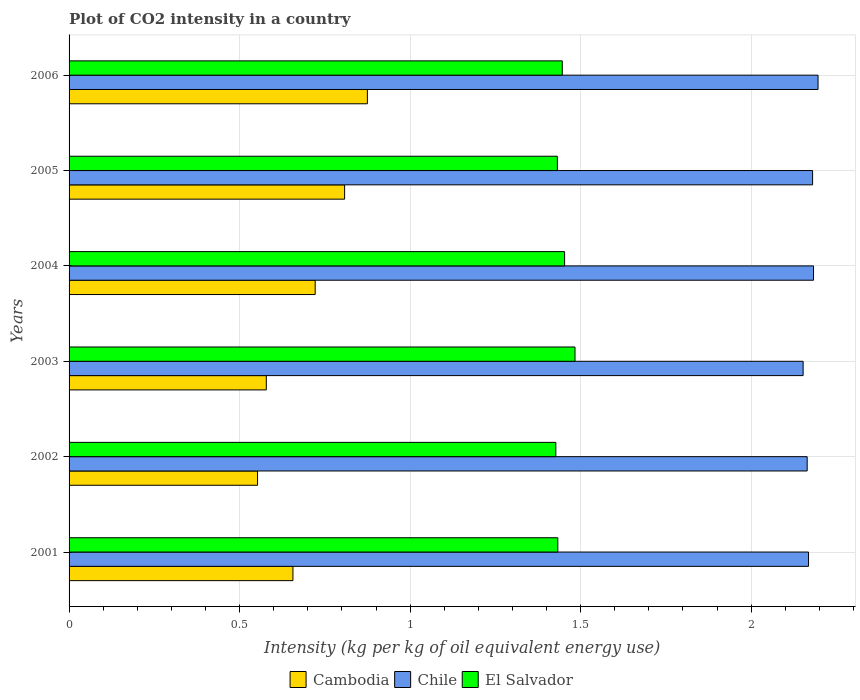How many different coloured bars are there?
Offer a very short reply. 3. Are the number of bars per tick equal to the number of legend labels?
Your answer should be very brief. Yes. Are the number of bars on each tick of the Y-axis equal?
Keep it short and to the point. Yes. How many bars are there on the 5th tick from the bottom?
Your response must be concise. 3. In how many cases, is the number of bars for a given year not equal to the number of legend labels?
Make the answer very short. 0. What is the CO2 intensity in in El Salvador in 2002?
Your answer should be compact. 1.43. Across all years, what is the maximum CO2 intensity in in El Salvador?
Your response must be concise. 1.48. Across all years, what is the minimum CO2 intensity in in Chile?
Your response must be concise. 2.15. What is the total CO2 intensity in in El Salvador in the graph?
Offer a terse response. 8.67. What is the difference between the CO2 intensity in in El Salvador in 2001 and that in 2006?
Offer a very short reply. -0.01. What is the difference between the CO2 intensity in in Chile in 2003 and the CO2 intensity in in Cambodia in 2002?
Provide a succinct answer. 1.6. What is the average CO2 intensity in in El Salvador per year?
Make the answer very short. 1.45. In the year 2002, what is the difference between the CO2 intensity in in Cambodia and CO2 intensity in in El Salvador?
Provide a succinct answer. -0.87. In how many years, is the CO2 intensity in in Cambodia greater than 2.1 kg?
Your response must be concise. 0. What is the ratio of the CO2 intensity in in El Salvador in 2005 to that in 2006?
Your answer should be compact. 0.99. Is the CO2 intensity in in Chile in 2001 less than that in 2006?
Offer a very short reply. Yes. What is the difference between the highest and the second highest CO2 intensity in in Chile?
Ensure brevity in your answer.  0.01. What is the difference between the highest and the lowest CO2 intensity in in El Salvador?
Your answer should be compact. 0.06. In how many years, is the CO2 intensity in in Chile greater than the average CO2 intensity in in Chile taken over all years?
Your answer should be compact. 3. Is the sum of the CO2 intensity in in Cambodia in 2003 and 2004 greater than the maximum CO2 intensity in in Chile across all years?
Your answer should be compact. No. What does the 1st bar from the top in 2006 represents?
Ensure brevity in your answer.  El Salvador. What does the 2nd bar from the bottom in 2001 represents?
Give a very brief answer. Chile. What is the difference between two consecutive major ticks on the X-axis?
Keep it short and to the point. 0.5. Does the graph contain any zero values?
Keep it short and to the point. No. How many legend labels are there?
Your answer should be very brief. 3. What is the title of the graph?
Provide a succinct answer. Plot of CO2 intensity in a country. What is the label or title of the X-axis?
Your answer should be very brief. Intensity (kg per kg of oil equivalent energy use). What is the label or title of the Y-axis?
Provide a short and direct response. Years. What is the Intensity (kg per kg of oil equivalent energy use) of Cambodia in 2001?
Provide a succinct answer. 0.66. What is the Intensity (kg per kg of oil equivalent energy use) of Chile in 2001?
Make the answer very short. 2.17. What is the Intensity (kg per kg of oil equivalent energy use) in El Salvador in 2001?
Provide a short and direct response. 1.43. What is the Intensity (kg per kg of oil equivalent energy use) in Cambodia in 2002?
Your answer should be compact. 0.55. What is the Intensity (kg per kg of oil equivalent energy use) of Chile in 2002?
Make the answer very short. 2.16. What is the Intensity (kg per kg of oil equivalent energy use) of El Salvador in 2002?
Keep it short and to the point. 1.43. What is the Intensity (kg per kg of oil equivalent energy use) in Cambodia in 2003?
Your answer should be compact. 0.58. What is the Intensity (kg per kg of oil equivalent energy use) of Chile in 2003?
Your answer should be compact. 2.15. What is the Intensity (kg per kg of oil equivalent energy use) of El Salvador in 2003?
Ensure brevity in your answer.  1.48. What is the Intensity (kg per kg of oil equivalent energy use) of Cambodia in 2004?
Provide a short and direct response. 0.72. What is the Intensity (kg per kg of oil equivalent energy use) of Chile in 2004?
Your answer should be very brief. 2.18. What is the Intensity (kg per kg of oil equivalent energy use) of El Salvador in 2004?
Your response must be concise. 1.45. What is the Intensity (kg per kg of oil equivalent energy use) in Cambodia in 2005?
Provide a succinct answer. 0.81. What is the Intensity (kg per kg of oil equivalent energy use) of Chile in 2005?
Provide a short and direct response. 2.18. What is the Intensity (kg per kg of oil equivalent energy use) in El Salvador in 2005?
Ensure brevity in your answer.  1.43. What is the Intensity (kg per kg of oil equivalent energy use) in Cambodia in 2006?
Offer a terse response. 0.87. What is the Intensity (kg per kg of oil equivalent energy use) in Chile in 2006?
Your answer should be compact. 2.2. What is the Intensity (kg per kg of oil equivalent energy use) in El Salvador in 2006?
Provide a succinct answer. 1.45. Across all years, what is the maximum Intensity (kg per kg of oil equivalent energy use) in Cambodia?
Offer a terse response. 0.87. Across all years, what is the maximum Intensity (kg per kg of oil equivalent energy use) of Chile?
Your response must be concise. 2.2. Across all years, what is the maximum Intensity (kg per kg of oil equivalent energy use) in El Salvador?
Ensure brevity in your answer.  1.48. Across all years, what is the minimum Intensity (kg per kg of oil equivalent energy use) in Cambodia?
Your response must be concise. 0.55. Across all years, what is the minimum Intensity (kg per kg of oil equivalent energy use) of Chile?
Provide a succinct answer. 2.15. Across all years, what is the minimum Intensity (kg per kg of oil equivalent energy use) of El Salvador?
Your answer should be compact. 1.43. What is the total Intensity (kg per kg of oil equivalent energy use) in Cambodia in the graph?
Your answer should be compact. 4.19. What is the total Intensity (kg per kg of oil equivalent energy use) in Chile in the graph?
Offer a very short reply. 13.04. What is the total Intensity (kg per kg of oil equivalent energy use) of El Salvador in the graph?
Provide a succinct answer. 8.67. What is the difference between the Intensity (kg per kg of oil equivalent energy use) in Cambodia in 2001 and that in 2002?
Your answer should be compact. 0.1. What is the difference between the Intensity (kg per kg of oil equivalent energy use) in Chile in 2001 and that in 2002?
Ensure brevity in your answer.  0. What is the difference between the Intensity (kg per kg of oil equivalent energy use) of El Salvador in 2001 and that in 2002?
Provide a short and direct response. 0.01. What is the difference between the Intensity (kg per kg of oil equivalent energy use) in Cambodia in 2001 and that in 2003?
Offer a terse response. 0.08. What is the difference between the Intensity (kg per kg of oil equivalent energy use) of Chile in 2001 and that in 2003?
Offer a very short reply. 0.02. What is the difference between the Intensity (kg per kg of oil equivalent energy use) of El Salvador in 2001 and that in 2003?
Your answer should be compact. -0.05. What is the difference between the Intensity (kg per kg of oil equivalent energy use) in Cambodia in 2001 and that in 2004?
Offer a very short reply. -0.07. What is the difference between the Intensity (kg per kg of oil equivalent energy use) in Chile in 2001 and that in 2004?
Give a very brief answer. -0.01. What is the difference between the Intensity (kg per kg of oil equivalent energy use) of El Salvador in 2001 and that in 2004?
Provide a short and direct response. -0.02. What is the difference between the Intensity (kg per kg of oil equivalent energy use) of Cambodia in 2001 and that in 2005?
Give a very brief answer. -0.15. What is the difference between the Intensity (kg per kg of oil equivalent energy use) of Chile in 2001 and that in 2005?
Your answer should be compact. -0.01. What is the difference between the Intensity (kg per kg of oil equivalent energy use) of El Salvador in 2001 and that in 2005?
Ensure brevity in your answer.  0. What is the difference between the Intensity (kg per kg of oil equivalent energy use) in Cambodia in 2001 and that in 2006?
Keep it short and to the point. -0.22. What is the difference between the Intensity (kg per kg of oil equivalent energy use) of Chile in 2001 and that in 2006?
Ensure brevity in your answer.  -0.03. What is the difference between the Intensity (kg per kg of oil equivalent energy use) in El Salvador in 2001 and that in 2006?
Provide a short and direct response. -0.01. What is the difference between the Intensity (kg per kg of oil equivalent energy use) of Cambodia in 2002 and that in 2003?
Give a very brief answer. -0.03. What is the difference between the Intensity (kg per kg of oil equivalent energy use) of Chile in 2002 and that in 2003?
Your response must be concise. 0.01. What is the difference between the Intensity (kg per kg of oil equivalent energy use) in El Salvador in 2002 and that in 2003?
Your answer should be compact. -0.06. What is the difference between the Intensity (kg per kg of oil equivalent energy use) of Cambodia in 2002 and that in 2004?
Your answer should be compact. -0.17. What is the difference between the Intensity (kg per kg of oil equivalent energy use) in Chile in 2002 and that in 2004?
Keep it short and to the point. -0.02. What is the difference between the Intensity (kg per kg of oil equivalent energy use) of El Salvador in 2002 and that in 2004?
Keep it short and to the point. -0.03. What is the difference between the Intensity (kg per kg of oil equivalent energy use) in Cambodia in 2002 and that in 2005?
Give a very brief answer. -0.26. What is the difference between the Intensity (kg per kg of oil equivalent energy use) of Chile in 2002 and that in 2005?
Your response must be concise. -0.02. What is the difference between the Intensity (kg per kg of oil equivalent energy use) of El Salvador in 2002 and that in 2005?
Offer a terse response. -0. What is the difference between the Intensity (kg per kg of oil equivalent energy use) in Cambodia in 2002 and that in 2006?
Your response must be concise. -0.32. What is the difference between the Intensity (kg per kg of oil equivalent energy use) in Chile in 2002 and that in 2006?
Offer a very short reply. -0.03. What is the difference between the Intensity (kg per kg of oil equivalent energy use) of El Salvador in 2002 and that in 2006?
Keep it short and to the point. -0.02. What is the difference between the Intensity (kg per kg of oil equivalent energy use) of Cambodia in 2003 and that in 2004?
Offer a very short reply. -0.14. What is the difference between the Intensity (kg per kg of oil equivalent energy use) of Chile in 2003 and that in 2004?
Provide a short and direct response. -0.03. What is the difference between the Intensity (kg per kg of oil equivalent energy use) in El Salvador in 2003 and that in 2004?
Provide a succinct answer. 0.03. What is the difference between the Intensity (kg per kg of oil equivalent energy use) of Cambodia in 2003 and that in 2005?
Your response must be concise. -0.23. What is the difference between the Intensity (kg per kg of oil equivalent energy use) of Chile in 2003 and that in 2005?
Keep it short and to the point. -0.03. What is the difference between the Intensity (kg per kg of oil equivalent energy use) of El Salvador in 2003 and that in 2005?
Give a very brief answer. 0.05. What is the difference between the Intensity (kg per kg of oil equivalent energy use) of Cambodia in 2003 and that in 2006?
Keep it short and to the point. -0.3. What is the difference between the Intensity (kg per kg of oil equivalent energy use) of Chile in 2003 and that in 2006?
Your response must be concise. -0.04. What is the difference between the Intensity (kg per kg of oil equivalent energy use) of El Salvador in 2003 and that in 2006?
Provide a short and direct response. 0.04. What is the difference between the Intensity (kg per kg of oil equivalent energy use) in Cambodia in 2004 and that in 2005?
Keep it short and to the point. -0.09. What is the difference between the Intensity (kg per kg of oil equivalent energy use) in Chile in 2004 and that in 2005?
Your answer should be compact. 0. What is the difference between the Intensity (kg per kg of oil equivalent energy use) of El Salvador in 2004 and that in 2005?
Offer a terse response. 0.02. What is the difference between the Intensity (kg per kg of oil equivalent energy use) of Cambodia in 2004 and that in 2006?
Your response must be concise. -0.15. What is the difference between the Intensity (kg per kg of oil equivalent energy use) of Chile in 2004 and that in 2006?
Give a very brief answer. -0.01. What is the difference between the Intensity (kg per kg of oil equivalent energy use) of El Salvador in 2004 and that in 2006?
Offer a terse response. 0.01. What is the difference between the Intensity (kg per kg of oil equivalent energy use) in Cambodia in 2005 and that in 2006?
Provide a short and direct response. -0.07. What is the difference between the Intensity (kg per kg of oil equivalent energy use) of Chile in 2005 and that in 2006?
Your answer should be compact. -0.02. What is the difference between the Intensity (kg per kg of oil equivalent energy use) in El Salvador in 2005 and that in 2006?
Your answer should be very brief. -0.01. What is the difference between the Intensity (kg per kg of oil equivalent energy use) of Cambodia in 2001 and the Intensity (kg per kg of oil equivalent energy use) of Chile in 2002?
Give a very brief answer. -1.51. What is the difference between the Intensity (kg per kg of oil equivalent energy use) of Cambodia in 2001 and the Intensity (kg per kg of oil equivalent energy use) of El Salvador in 2002?
Give a very brief answer. -0.77. What is the difference between the Intensity (kg per kg of oil equivalent energy use) in Chile in 2001 and the Intensity (kg per kg of oil equivalent energy use) in El Salvador in 2002?
Provide a succinct answer. 0.74. What is the difference between the Intensity (kg per kg of oil equivalent energy use) in Cambodia in 2001 and the Intensity (kg per kg of oil equivalent energy use) in Chile in 2003?
Your answer should be very brief. -1.5. What is the difference between the Intensity (kg per kg of oil equivalent energy use) in Cambodia in 2001 and the Intensity (kg per kg of oil equivalent energy use) in El Salvador in 2003?
Make the answer very short. -0.83. What is the difference between the Intensity (kg per kg of oil equivalent energy use) of Chile in 2001 and the Intensity (kg per kg of oil equivalent energy use) of El Salvador in 2003?
Keep it short and to the point. 0.68. What is the difference between the Intensity (kg per kg of oil equivalent energy use) in Cambodia in 2001 and the Intensity (kg per kg of oil equivalent energy use) in Chile in 2004?
Give a very brief answer. -1.53. What is the difference between the Intensity (kg per kg of oil equivalent energy use) in Cambodia in 2001 and the Intensity (kg per kg of oil equivalent energy use) in El Salvador in 2004?
Your answer should be very brief. -0.8. What is the difference between the Intensity (kg per kg of oil equivalent energy use) in Chile in 2001 and the Intensity (kg per kg of oil equivalent energy use) in El Salvador in 2004?
Your response must be concise. 0.72. What is the difference between the Intensity (kg per kg of oil equivalent energy use) of Cambodia in 2001 and the Intensity (kg per kg of oil equivalent energy use) of Chile in 2005?
Give a very brief answer. -1.52. What is the difference between the Intensity (kg per kg of oil equivalent energy use) of Cambodia in 2001 and the Intensity (kg per kg of oil equivalent energy use) of El Salvador in 2005?
Your answer should be compact. -0.78. What is the difference between the Intensity (kg per kg of oil equivalent energy use) of Chile in 2001 and the Intensity (kg per kg of oil equivalent energy use) of El Salvador in 2005?
Ensure brevity in your answer.  0.74. What is the difference between the Intensity (kg per kg of oil equivalent energy use) of Cambodia in 2001 and the Intensity (kg per kg of oil equivalent energy use) of Chile in 2006?
Make the answer very short. -1.54. What is the difference between the Intensity (kg per kg of oil equivalent energy use) of Cambodia in 2001 and the Intensity (kg per kg of oil equivalent energy use) of El Salvador in 2006?
Provide a short and direct response. -0.79. What is the difference between the Intensity (kg per kg of oil equivalent energy use) in Chile in 2001 and the Intensity (kg per kg of oil equivalent energy use) in El Salvador in 2006?
Your response must be concise. 0.72. What is the difference between the Intensity (kg per kg of oil equivalent energy use) in Cambodia in 2002 and the Intensity (kg per kg of oil equivalent energy use) in Chile in 2003?
Make the answer very short. -1.6. What is the difference between the Intensity (kg per kg of oil equivalent energy use) of Cambodia in 2002 and the Intensity (kg per kg of oil equivalent energy use) of El Salvador in 2003?
Keep it short and to the point. -0.93. What is the difference between the Intensity (kg per kg of oil equivalent energy use) in Chile in 2002 and the Intensity (kg per kg of oil equivalent energy use) in El Salvador in 2003?
Give a very brief answer. 0.68. What is the difference between the Intensity (kg per kg of oil equivalent energy use) in Cambodia in 2002 and the Intensity (kg per kg of oil equivalent energy use) in Chile in 2004?
Provide a succinct answer. -1.63. What is the difference between the Intensity (kg per kg of oil equivalent energy use) in Cambodia in 2002 and the Intensity (kg per kg of oil equivalent energy use) in El Salvador in 2004?
Keep it short and to the point. -0.9. What is the difference between the Intensity (kg per kg of oil equivalent energy use) in Chile in 2002 and the Intensity (kg per kg of oil equivalent energy use) in El Salvador in 2004?
Your answer should be very brief. 0.71. What is the difference between the Intensity (kg per kg of oil equivalent energy use) in Cambodia in 2002 and the Intensity (kg per kg of oil equivalent energy use) in Chile in 2005?
Provide a short and direct response. -1.63. What is the difference between the Intensity (kg per kg of oil equivalent energy use) of Cambodia in 2002 and the Intensity (kg per kg of oil equivalent energy use) of El Salvador in 2005?
Your response must be concise. -0.88. What is the difference between the Intensity (kg per kg of oil equivalent energy use) in Chile in 2002 and the Intensity (kg per kg of oil equivalent energy use) in El Salvador in 2005?
Provide a short and direct response. 0.73. What is the difference between the Intensity (kg per kg of oil equivalent energy use) in Cambodia in 2002 and the Intensity (kg per kg of oil equivalent energy use) in Chile in 2006?
Make the answer very short. -1.64. What is the difference between the Intensity (kg per kg of oil equivalent energy use) of Cambodia in 2002 and the Intensity (kg per kg of oil equivalent energy use) of El Salvador in 2006?
Offer a very short reply. -0.89. What is the difference between the Intensity (kg per kg of oil equivalent energy use) in Chile in 2002 and the Intensity (kg per kg of oil equivalent energy use) in El Salvador in 2006?
Offer a very short reply. 0.72. What is the difference between the Intensity (kg per kg of oil equivalent energy use) in Cambodia in 2003 and the Intensity (kg per kg of oil equivalent energy use) in Chile in 2004?
Your answer should be compact. -1.6. What is the difference between the Intensity (kg per kg of oil equivalent energy use) of Cambodia in 2003 and the Intensity (kg per kg of oil equivalent energy use) of El Salvador in 2004?
Offer a terse response. -0.87. What is the difference between the Intensity (kg per kg of oil equivalent energy use) of Chile in 2003 and the Intensity (kg per kg of oil equivalent energy use) of El Salvador in 2004?
Your response must be concise. 0.7. What is the difference between the Intensity (kg per kg of oil equivalent energy use) in Cambodia in 2003 and the Intensity (kg per kg of oil equivalent energy use) in Chile in 2005?
Give a very brief answer. -1.6. What is the difference between the Intensity (kg per kg of oil equivalent energy use) in Cambodia in 2003 and the Intensity (kg per kg of oil equivalent energy use) in El Salvador in 2005?
Provide a succinct answer. -0.85. What is the difference between the Intensity (kg per kg of oil equivalent energy use) of Chile in 2003 and the Intensity (kg per kg of oil equivalent energy use) of El Salvador in 2005?
Offer a terse response. 0.72. What is the difference between the Intensity (kg per kg of oil equivalent energy use) in Cambodia in 2003 and the Intensity (kg per kg of oil equivalent energy use) in Chile in 2006?
Provide a short and direct response. -1.62. What is the difference between the Intensity (kg per kg of oil equivalent energy use) of Cambodia in 2003 and the Intensity (kg per kg of oil equivalent energy use) of El Salvador in 2006?
Keep it short and to the point. -0.87. What is the difference between the Intensity (kg per kg of oil equivalent energy use) in Chile in 2003 and the Intensity (kg per kg of oil equivalent energy use) in El Salvador in 2006?
Your answer should be compact. 0.71. What is the difference between the Intensity (kg per kg of oil equivalent energy use) of Cambodia in 2004 and the Intensity (kg per kg of oil equivalent energy use) of Chile in 2005?
Ensure brevity in your answer.  -1.46. What is the difference between the Intensity (kg per kg of oil equivalent energy use) in Cambodia in 2004 and the Intensity (kg per kg of oil equivalent energy use) in El Salvador in 2005?
Offer a very short reply. -0.71. What is the difference between the Intensity (kg per kg of oil equivalent energy use) in Chile in 2004 and the Intensity (kg per kg of oil equivalent energy use) in El Salvador in 2005?
Offer a terse response. 0.75. What is the difference between the Intensity (kg per kg of oil equivalent energy use) of Cambodia in 2004 and the Intensity (kg per kg of oil equivalent energy use) of Chile in 2006?
Keep it short and to the point. -1.47. What is the difference between the Intensity (kg per kg of oil equivalent energy use) in Cambodia in 2004 and the Intensity (kg per kg of oil equivalent energy use) in El Salvador in 2006?
Your response must be concise. -0.72. What is the difference between the Intensity (kg per kg of oil equivalent energy use) of Chile in 2004 and the Intensity (kg per kg of oil equivalent energy use) of El Salvador in 2006?
Your answer should be compact. 0.74. What is the difference between the Intensity (kg per kg of oil equivalent energy use) in Cambodia in 2005 and the Intensity (kg per kg of oil equivalent energy use) in Chile in 2006?
Provide a short and direct response. -1.39. What is the difference between the Intensity (kg per kg of oil equivalent energy use) of Cambodia in 2005 and the Intensity (kg per kg of oil equivalent energy use) of El Salvador in 2006?
Keep it short and to the point. -0.64. What is the difference between the Intensity (kg per kg of oil equivalent energy use) in Chile in 2005 and the Intensity (kg per kg of oil equivalent energy use) in El Salvador in 2006?
Provide a succinct answer. 0.73. What is the average Intensity (kg per kg of oil equivalent energy use) of Cambodia per year?
Offer a terse response. 0.7. What is the average Intensity (kg per kg of oil equivalent energy use) of Chile per year?
Your response must be concise. 2.17. What is the average Intensity (kg per kg of oil equivalent energy use) of El Salvador per year?
Your answer should be compact. 1.45. In the year 2001, what is the difference between the Intensity (kg per kg of oil equivalent energy use) in Cambodia and Intensity (kg per kg of oil equivalent energy use) in Chile?
Keep it short and to the point. -1.51. In the year 2001, what is the difference between the Intensity (kg per kg of oil equivalent energy use) in Cambodia and Intensity (kg per kg of oil equivalent energy use) in El Salvador?
Provide a short and direct response. -0.78. In the year 2001, what is the difference between the Intensity (kg per kg of oil equivalent energy use) of Chile and Intensity (kg per kg of oil equivalent energy use) of El Salvador?
Offer a terse response. 0.74. In the year 2002, what is the difference between the Intensity (kg per kg of oil equivalent energy use) in Cambodia and Intensity (kg per kg of oil equivalent energy use) in Chile?
Ensure brevity in your answer.  -1.61. In the year 2002, what is the difference between the Intensity (kg per kg of oil equivalent energy use) in Cambodia and Intensity (kg per kg of oil equivalent energy use) in El Salvador?
Provide a succinct answer. -0.87. In the year 2002, what is the difference between the Intensity (kg per kg of oil equivalent energy use) in Chile and Intensity (kg per kg of oil equivalent energy use) in El Salvador?
Provide a succinct answer. 0.74. In the year 2003, what is the difference between the Intensity (kg per kg of oil equivalent energy use) of Cambodia and Intensity (kg per kg of oil equivalent energy use) of Chile?
Your answer should be very brief. -1.57. In the year 2003, what is the difference between the Intensity (kg per kg of oil equivalent energy use) in Cambodia and Intensity (kg per kg of oil equivalent energy use) in El Salvador?
Ensure brevity in your answer.  -0.91. In the year 2003, what is the difference between the Intensity (kg per kg of oil equivalent energy use) of Chile and Intensity (kg per kg of oil equivalent energy use) of El Salvador?
Offer a very short reply. 0.67. In the year 2004, what is the difference between the Intensity (kg per kg of oil equivalent energy use) in Cambodia and Intensity (kg per kg of oil equivalent energy use) in Chile?
Offer a terse response. -1.46. In the year 2004, what is the difference between the Intensity (kg per kg of oil equivalent energy use) in Cambodia and Intensity (kg per kg of oil equivalent energy use) in El Salvador?
Make the answer very short. -0.73. In the year 2004, what is the difference between the Intensity (kg per kg of oil equivalent energy use) in Chile and Intensity (kg per kg of oil equivalent energy use) in El Salvador?
Your response must be concise. 0.73. In the year 2005, what is the difference between the Intensity (kg per kg of oil equivalent energy use) in Cambodia and Intensity (kg per kg of oil equivalent energy use) in Chile?
Give a very brief answer. -1.37. In the year 2005, what is the difference between the Intensity (kg per kg of oil equivalent energy use) in Cambodia and Intensity (kg per kg of oil equivalent energy use) in El Salvador?
Your answer should be very brief. -0.62. In the year 2005, what is the difference between the Intensity (kg per kg of oil equivalent energy use) in Chile and Intensity (kg per kg of oil equivalent energy use) in El Salvador?
Ensure brevity in your answer.  0.75. In the year 2006, what is the difference between the Intensity (kg per kg of oil equivalent energy use) of Cambodia and Intensity (kg per kg of oil equivalent energy use) of Chile?
Provide a short and direct response. -1.32. In the year 2006, what is the difference between the Intensity (kg per kg of oil equivalent energy use) of Cambodia and Intensity (kg per kg of oil equivalent energy use) of El Salvador?
Ensure brevity in your answer.  -0.57. What is the ratio of the Intensity (kg per kg of oil equivalent energy use) in Cambodia in 2001 to that in 2002?
Offer a terse response. 1.19. What is the ratio of the Intensity (kg per kg of oil equivalent energy use) of Chile in 2001 to that in 2002?
Ensure brevity in your answer.  1. What is the ratio of the Intensity (kg per kg of oil equivalent energy use) of Cambodia in 2001 to that in 2003?
Provide a short and direct response. 1.13. What is the ratio of the Intensity (kg per kg of oil equivalent energy use) in Chile in 2001 to that in 2003?
Provide a succinct answer. 1.01. What is the ratio of the Intensity (kg per kg of oil equivalent energy use) of El Salvador in 2001 to that in 2003?
Your response must be concise. 0.97. What is the ratio of the Intensity (kg per kg of oil equivalent energy use) of Cambodia in 2001 to that in 2004?
Keep it short and to the point. 0.91. What is the ratio of the Intensity (kg per kg of oil equivalent energy use) of El Salvador in 2001 to that in 2004?
Offer a very short reply. 0.99. What is the ratio of the Intensity (kg per kg of oil equivalent energy use) of Cambodia in 2001 to that in 2005?
Your response must be concise. 0.81. What is the ratio of the Intensity (kg per kg of oil equivalent energy use) of Chile in 2001 to that in 2005?
Your answer should be compact. 0.99. What is the ratio of the Intensity (kg per kg of oil equivalent energy use) of Cambodia in 2001 to that in 2006?
Keep it short and to the point. 0.75. What is the ratio of the Intensity (kg per kg of oil equivalent energy use) in Chile in 2001 to that in 2006?
Provide a succinct answer. 0.99. What is the ratio of the Intensity (kg per kg of oil equivalent energy use) in El Salvador in 2001 to that in 2006?
Provide a succinct answer. 0.99. What is the ratio of the Intensity (kg per kg of oil equivalent energy use) in Cambodia in 2002 to that in 2003?
Ensure brevity in your answer.  0.96. What is the ratio of the Intensity (kg per kg of oil equivalent energy use) of El Salvador in 2002 to that in 2003?
Offer a very short reply. 0.96. What is the ratio of the Intensity (kg per kg of oil equivalent energy use) in Cambodia in 2002 to that in 2004?
Ensure brevity in your answer.  0.77. What is the ratio of the Intensity (kg per kg of oil equivalent energy use) of El Salvador in 2002 to that in 2004?
Your answer should be compact. 0.98. What is the ratio of the Intensity (kg per kg of oil equivalent energy use) of Cambodia in 2002 to that in 2005?
Your answer should be very brief. 0.68. What is the ratio of the Intensity (kg per kg of oil equivalent energy use) in El Salvador in 2002 to that in 2005?
Provide a short and direct response. 1. What is the ratio of the Intensity (kg per kg of oil equivalent energy use) of Cambodia in 2002 to that in 2006?
Provide a succinct answer. 0.63. What is the ratio of the Intensity (kg per kg of oil equivalent energy use) in Chile in 2002 to that in 2006?
Provide a short and direct response. 0.99. What is the ratio of the Intensity (kg per kg of oil equivalent energy use) of El Salvador in 2002 to that in 2006?
Your answer should be very brief. 0.99. What is the ratio of the Intensity (kg per kg of oil equivalent energy use) of Cambodia in 2003 to that in 2004?
Keep it short and to the point. 0.8. What is the ratio of the Intensity (kg per kg of oil equivalent energy use) of Chile in 2003 to that in 2004?
Keep it short and to the point. 0.99. What is the ratio of the Intensity (kg per kg of oil equivalent energy use) in Cambodia in 2003 to that in 2005?
Offer a very short reply. 0.72. What is the ratio of the Intensity (kg per kg of oil equivalent energy use) in Chile in 2003 to that in 2005?
Your answer should be compact. 0.99. What is the ratio of the Intensity (kg per kg of oil equivalent energy use) of El Salvador in 2003 to that in 2005?
Offer a terse response. 1.04. What is the ratio of the Intensity (kg per kg of oil equivalent energy use) in Cambodia in 2003 to that in 2006?
Keep it short and to the point. 0.66. What is the ratio of the Intensity (kg per kg of oil equivalent energy use) in Chile in 2003 to that in 2006?
Give a very brief answer. 0.98. What is the ratio of the Intensity (kg per kg of oil equivalent energy use) in El Salvador in 2003 to that in 2006?
Offer a very short reply. 1.03. What is the ratio of the Intensity (kg per kg of oil equivalent energy use) in Cambodia in 2004 to that in 2005?
Provide a short and direct response. 0.89. What is the ratio of the Intensity (kg per kg of oil equivalent energy use) in Chile in 2004 to that in 2005?
Your answer should be compact. 1. What is the ratio of the Intensity (kg per kg of oil equivalent energy use) in El Salvador in 2004 to that in 2005?
Offer a terse response. 1.01. What is the ratio of the Intensity (kg per kg of oil equivalent energy use) of Cambodia in 2004 to that in 2006?
Offer a very short reply. 0.82. What is the ratio of the Intensity (kg per kg of oil equivalent energy use) in Chile in 2004 to that in 2006?
Your response must be concise. 0.99. What is the ratio of the Intensity (kg per kg of oil equivalent energy use) in Cambodia in 2005 to that in 2006?
Your answer should be very brief. 0.92. What is the difference between the highest and the second highest Intensity (kg per kg of oil equivalent energy use) of Cambodia?
Provide a succinct answer. 0.07. What is the difference between the highest and the second highest Intensity (kg per kg of oil equivalent energy use) in Chile?
Offer a very short reply. 0.01. What is the difference between the highest and the second highest Intensity (kg per kg of oil equivalent energy use) of El Salvador?
Your response must be concise. 0.03. What is the difference between the highest and the lowest Intensity (kg per kg of oil equivalent energy use) in Cambodia?
Provide a succinct answer. 0.32. What is the difference between the highest and the lowest Intensity (kg per kg of oil equivalent energy use) in Chile?
Keep it short and to the point. 0.04. What is the difference between the highest and the lowest Intensity (kg per kg of oil equivalent energy use) in El Salvador?
Offer a very short reply. 0.06. 